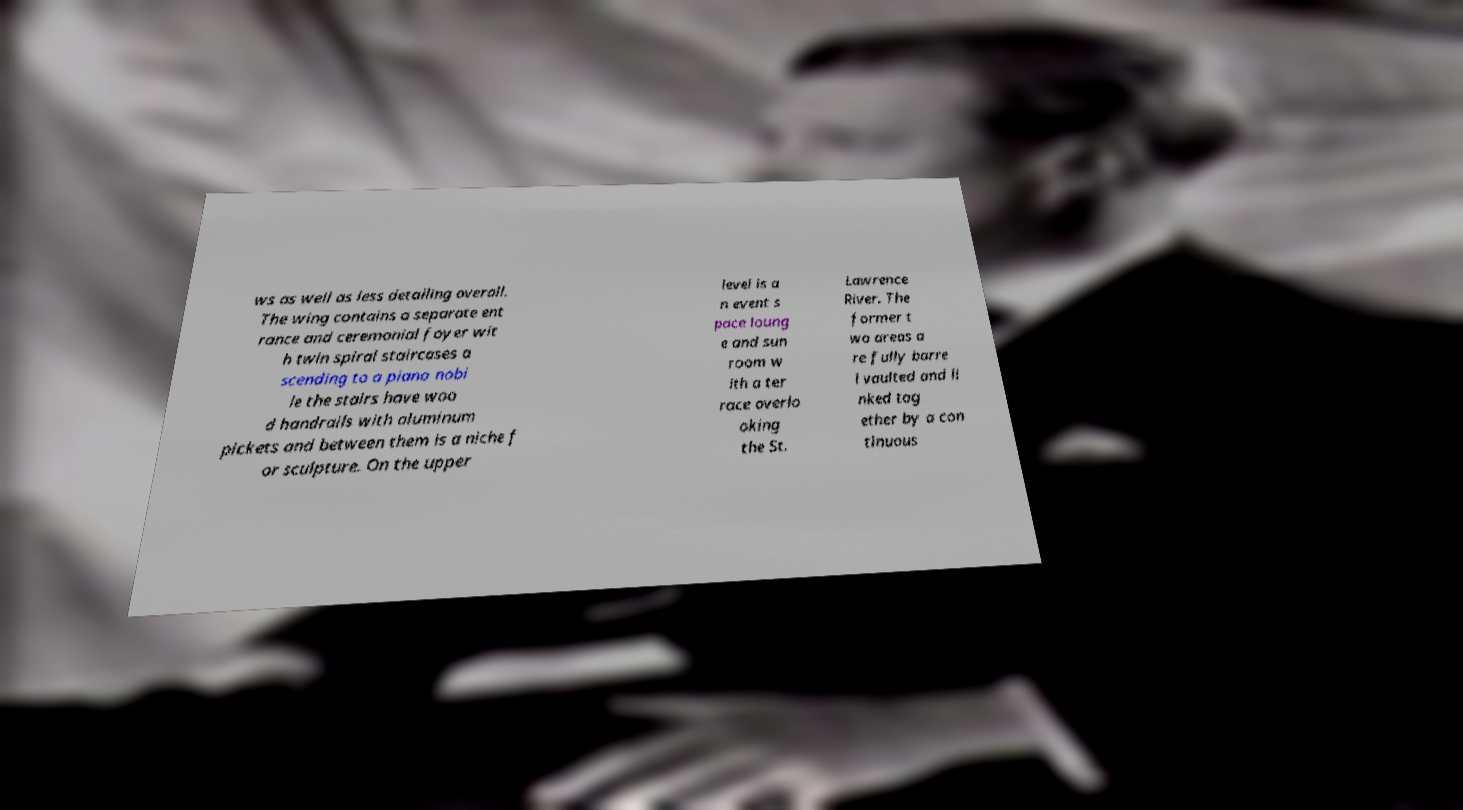Can you read and provide the text displayed in the image?This photo seems to have some interesting text. Can you extract and type it out for me? ws as well as less detailing overall. The wing contains a separate ent rance and ceremonial foyer wit h twin spiral staircases a scending to a piano nobi le the stairs have woo d handrails with aluminum pickets and between them is a niche f or sculpture. On the upper level is a n event s pace loung e and sun room w ith a ter race overlo oking the St. Lawrence River. The former t wo areas a re fully barre l vaulted and li nked tog ether by a con tinuous 